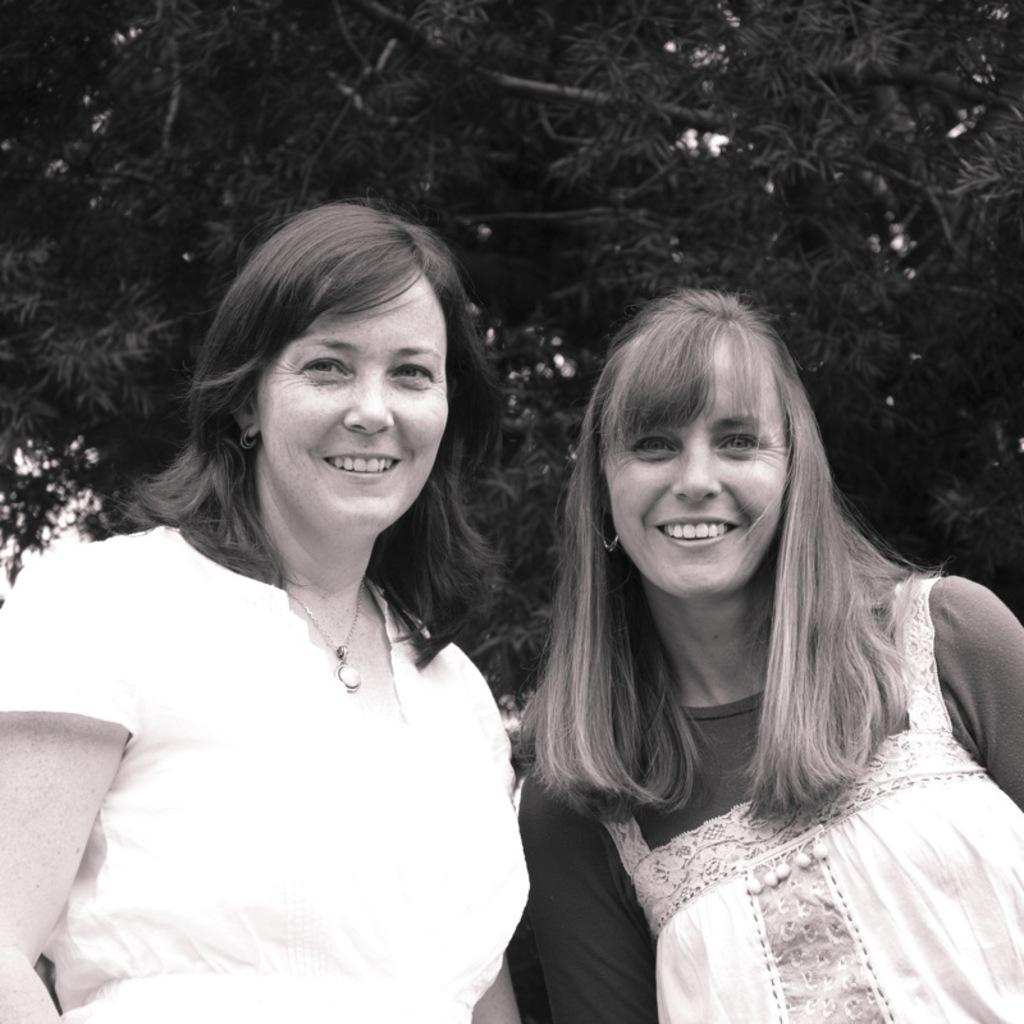How many women are present in the image? There are two women in the image. What expression do the women have in the image? The women are smiling in the image. What can be seen in the background of the image? There are trees visible in the background of the image. What type of toy can be seen in the hands of the women in the image? There is no toy present in the image; the women are not holding any objects. What is the base material of the trees visible in the background of the image? The provided facts do not specify the base material of the trees; only their presence is mentioned. 